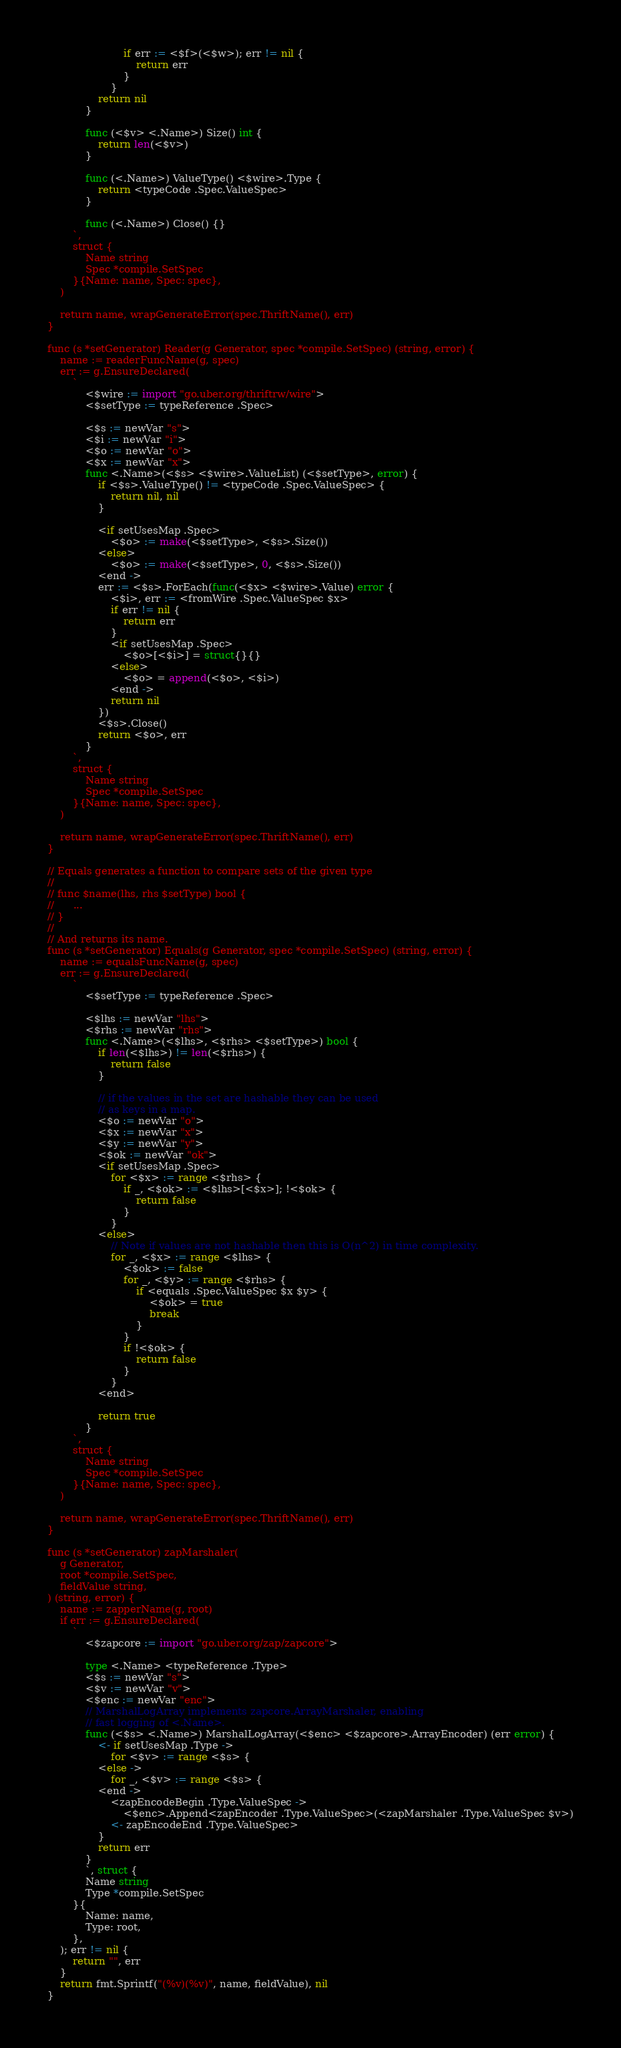<code> <loc_0><loc_0><loc_500><loc_500><_Go_>
						if err := <$f>(<$w>); err != nil {
							return err
						}
					}
				return nil
			}

			func (<$v> <.Name>) Size() int {
				return len(<$v>)
			}

			func (<.Name>) ValueType() <$wire>.Type {
				return <typeCode .Spec.ValueSpec>
			}

			func (<.Name>) Close() {}
		`,
		struct {
			Name string
			Spec *compile.SetSpec
		}{Name: name, Spec: spec},
	)

	return name, wrapGenerateError(spec.ThriftName(), err)
}

func (s *setGenerator) Reader(g Generator, spec *compile.SetSpec) (string, error) {
	name := readerFuncName(g, spec)
	err := g.EnsureDeclared(
		`
			<$wire := import "go.uber.org/thriftrw/wire">
			<$setType := typeReference .Spec>

			<$s := newVar "s">
			<$i := newVar "i">
			<$o := newVar "o">
			<$x := newVar "x">
			func <.Name>(<$s> <$wire>.ValueList) (<$setType>, error) {
				if <$s>.ValueType() != <typeCode .Spec.ValueSpec> {
					return nil, nil
				}

				<if setUsesMap .Spec>
					<$o> := make(<$setType>, <$s>.Size())
				<else>
					<$o> := make(<$setType>, 0, <$s>.Size())
				<end ->
				err := <$s>.ForEach(func(<$x> <$wire>.Value) error {
					<$i>, err := <fromWire .Spec.ValueSpec $x>
					if err != nil {
						return err
					}
					<if setUsesMap .Spec>
						<$o>[<$i>] = struct{}{}
					<else>
						<$o> = append(<$o>, <$i>)
					<end ->
					return nil
				})
				<$s>.Close()
				return <$o>, err
			}
		`,
		struct {
			Name string
			Spec *compile.SetSpec
		}{Name: name, Spec: spec},
	)

	return name, wrapGenerateError(spec.ThriftName(), err)
}

// Equals generates a function to compare sets of the given type
//
// func $name(lhs, rhs $setType) bool {
//      ...
// }
//
// And returns its name.
func (s *setGenerator) Equals(g Generator, spec *compile.SetSpec) (string, error) {
	name := equalsFuncName(g, spec)
	err := g.EnsureDeclared(
		`
			<$setType := typeReference .Spec>

			<$lhs := newVar "lhs">
			<$rhs := newVar "rhs">
			func <.Name>(<$lhs>, <$rhs> <$setType>) bool {
				if len(<$lhs>) != len(<$rhs>) {
					return false
				}

				// if the values in the set are hashable they can be used
				// as keys in a map.
				<$o := newVar "o">
				<$x := newVar "x">
				<$y := newVar "y">
				<$ok := newVar "ok">
				<if setUsesMap .Spec>
					for <$x> := range <$rhs> {
						if _, <$ok> := <$lhs>[<$x>]; !<$ok> {
							return false
						}
					}
				<else>
					// Note if values are not hashable then this is O(n^2) in time complexity.
					for _, <$x> := range <$lhs> {
						<$ok> := false
						for _, <$y> := range <$rhs> {
							if <equals .Spec.ValueSpec $x $y> {
								<$ok> = true
								break
							}
						}
						if !<$ok> {
							return false
						}
					}
				<end>

				return true
			}
		`,
		struct {
			Name string
			Spec *compile.SetSpec
		}{Name: name, Spec: spec},
	)

	return name, wrapGenerateError(spec.ThriftName(), err)
}

func (s *setGenerator) zapMarshaler(
	g Generator,
	root *compile.SetSpec,
	fieldValue string,
) (string, error) {
	name := zapperName(g, root)
	if err := g.EnsureDeclared(
		`
			<$zapcore := import "go.uber.org/zap/zapcore">

			type <.Name> <typeReference .Type>
			<$s := newVar "s">
			<$v := newVar "v">
			<$enc := newVar "enc">
			// MarshalLogArray implements zapcore.ArrayMarshaler, enabling
			// fast logging of <.Name>.
			func (<$s> <.Name>) MarshalLogArray(<$enc> <$zapcore>.ArrayEncoder) (err error) {
				<- if setUsesMap .Type ->
					for <$v> := range <$s> {
				<else ->
					for _, <$v> := range <$s> {
				<end ->
					<zapEncodeBegin .Type.ValueSpec ->
						<$enc>.Append<zapEncoder .Type.ValueSpec>(<zapMarshaler .Type.ValueSpec $v>)
					<- zapEncodeEnd .Type.ValueSpec>
				}
				return err
			}
			`, struct {
			Name string
			Type *compile.SetSpec
		}{
			Name: name,
			Type: root,
		},
	); err != nil {
		return "", err
	}
	return fmt.Sprintf("(%v)(%v)", name, fieldValue), nil
}
</code> 